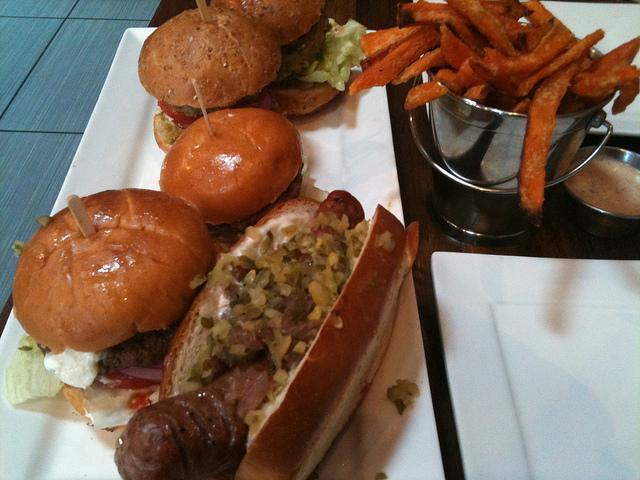Evaluate: Does the caption "The bowl is away from the hot dog." match the image?
Answer yes or no. Yes. 